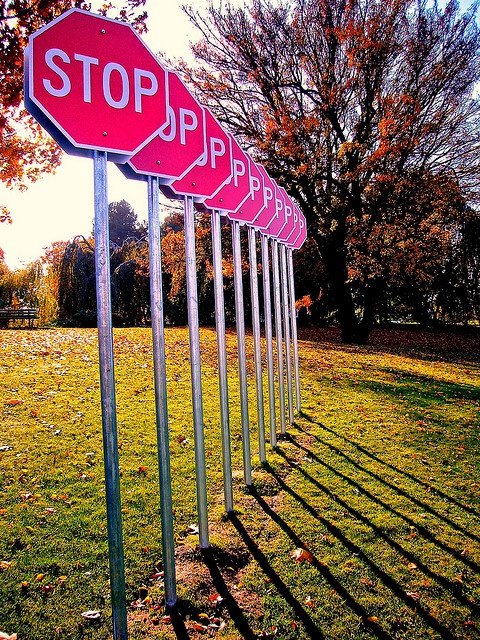Describe the objects in this image and their specific colors. I can see stop sign in black, brown, and violet tones, stop sign in black, brown, violet, and lavender tones, stop sign in black, brown, lavender, violet, and purple tones, stop sign in black, magenta, brown, lavender, and purple tones, and stop sign in black, magenta, lavender, purple, and violet tones in this image. 